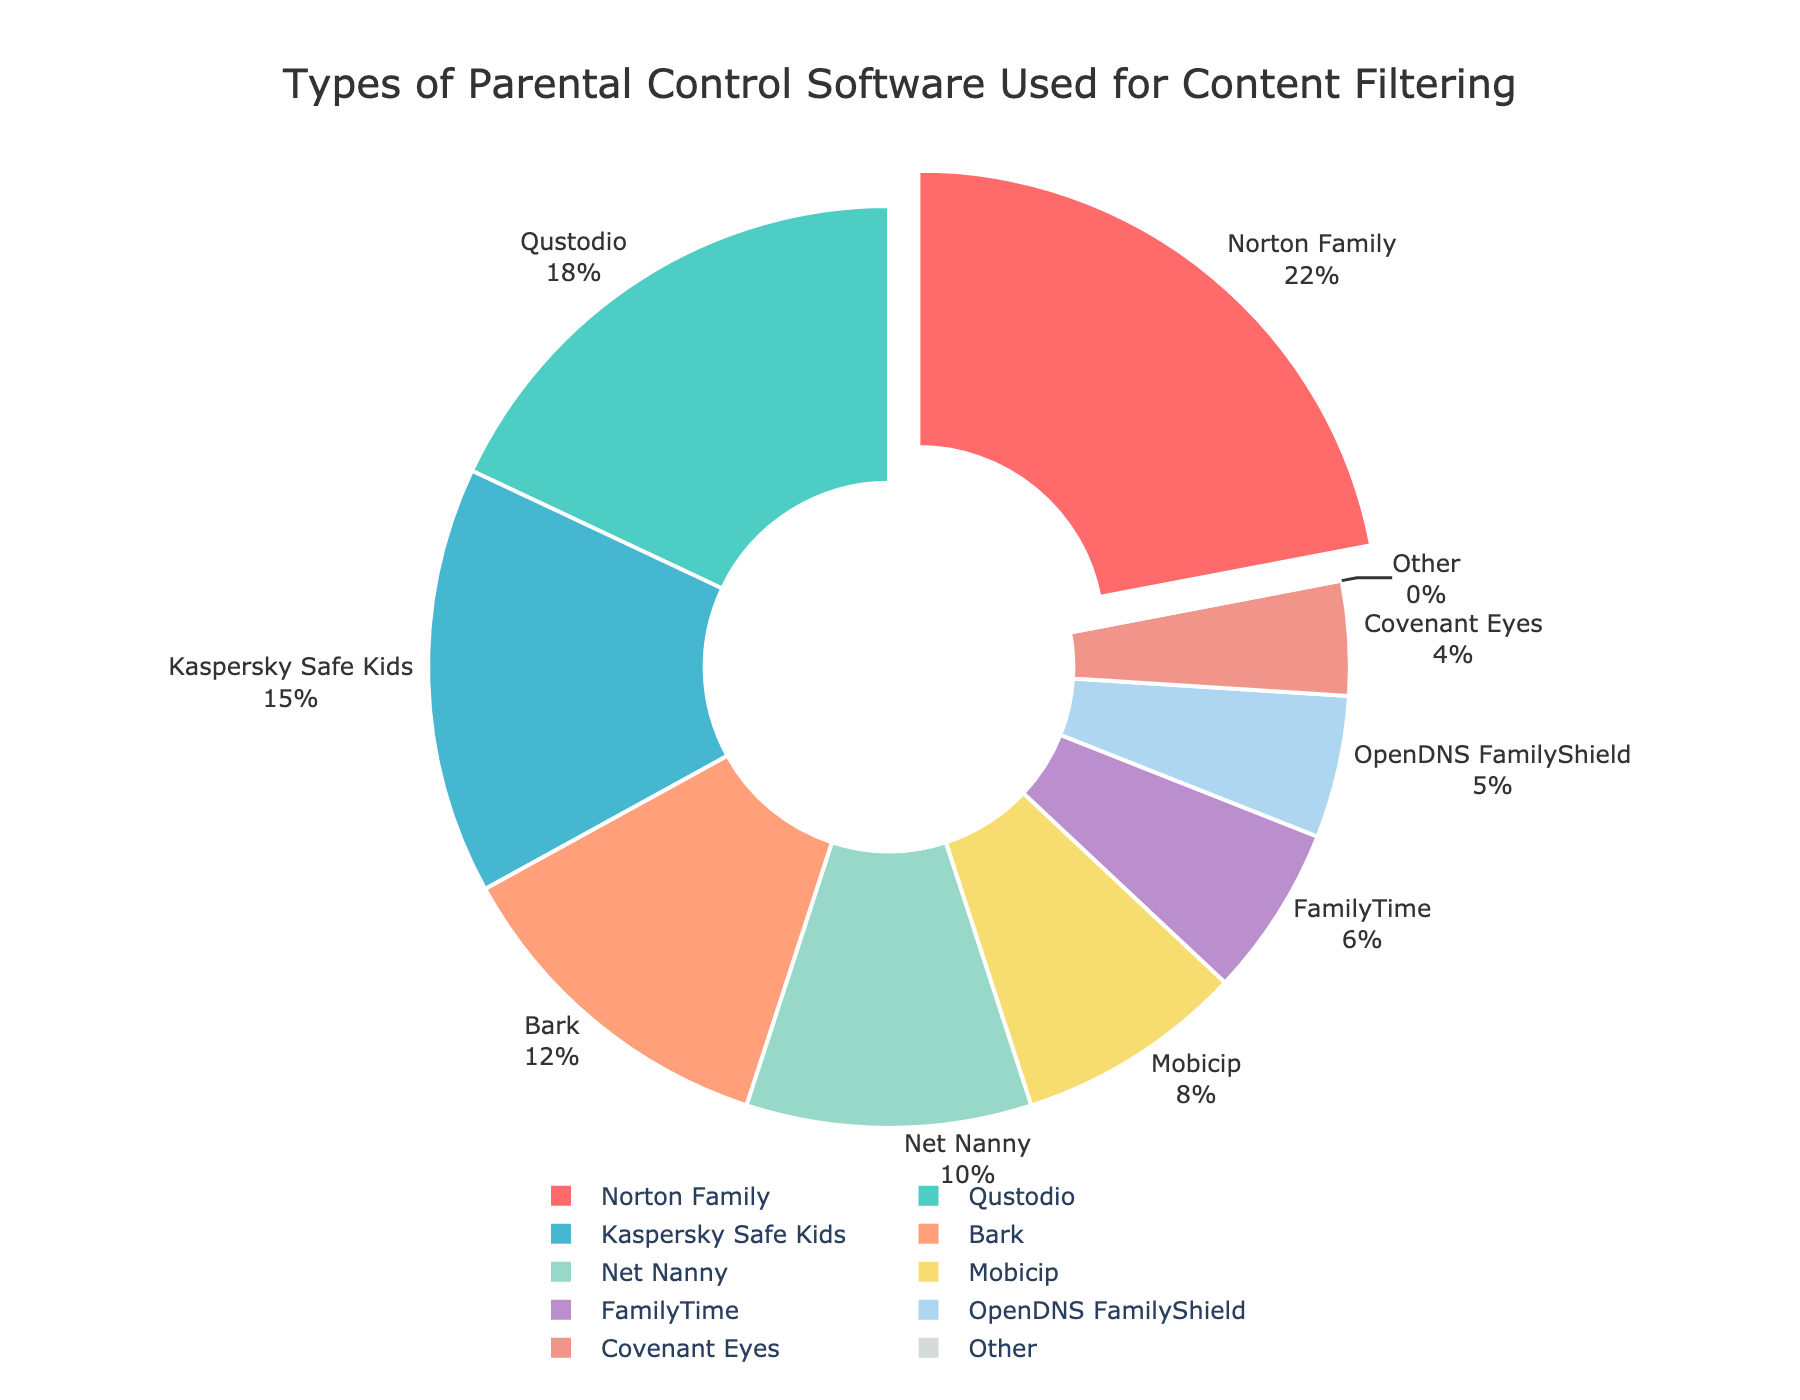What's the most commonly used parental control software? The pie chart shows that Norton Family has the largest segment pulled out, indicating it is the most commonly used parental control software.
Answer: Norton Family Which software has the second-highest usage percentage? The pie chart segments are sorted, with the second-largest segment representing Qustodio, which is the software with the second-highest usage.
Answer: Qustodio What's the total percentage of usage for Net Nanny and Bark combined? The pie chart shows 10% for Net Nanny and 12% for Bark. Their total usage is the sum of these two percentages: 10% + 12% = 22%.
Answer: 22% Are there more people using Kaspersky Safe Kids or Mobicip? By comparing the segments, the pie chart shows Kaspersky Safe Kids at 15% and Mobicip at 8%. Kaspersky Safe Kids has a higher percentage.
Answer: Kaspersky Safe Kids Which software has the smallest usage percentage? The pie chart shows Covenant Eyes with the smallest segment at 4%, making it the software with the smallest usage percentage.
Answer: Covenant Eyes What's the percentage difference between FamilyTime and OpenDNS FamilyShield? FamilyTime is at 6% and OpenDNS FamilyShield is at 5%. The difference is calculated as 6% - 5% = 1%.
Answer: 1% Which software is represented by the segment colored in the darkest shade of green? By observing the colors in the pie chart, the darkest shade of green corresponds to Qustodio with 18%.
Answer: Qustodio How much larger is the usage of Norton Family compared to FamilyTime? Norton Family is at 22% and FamilyTime is at 6%. The difference is 22% - 6% = 16%.
Answer: 16% What is the proportion of users not using 'Other' software? The 'Other' category is at 0%, meaning 100% of users are using the listed software.
Answer: 100% What is the combined percentage of the three least used software? The three least used software are FamilyTime (6%), OpenDNS FamilyShield (5%), and Covenant Eyes (4%). Their combined percentage is 6% + 5% + 4% = 15%.
Answer: 15% 